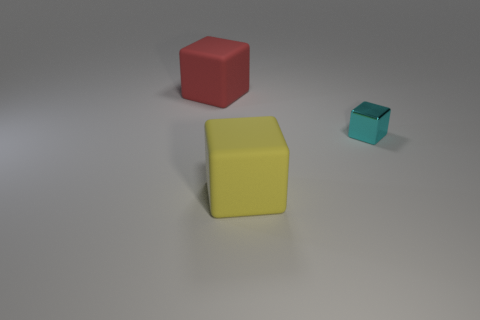Subtract all red cubes. Subtract all cyan spheres. How many cubes are left? 2 Subtract all gray cylinders. How many gray cubes are left? 0 Add 2 yellows. How many cyans exist? 0 Subtract all yellow matte blocks. Subtract all tiny blue cubes. How many objects are left? 2 Add 2 red matte cubes. How many red matte cubes are left? 3 Add 1 large yellow objects. How many large yellow objects exist? 2 Add 3 big yellow matte things. How many objects exist? 6 Subtract all cyan cubes. How many cubes are left? 2 Subtract all tiny cyan cubes. How many cubes are left? 2 Subtract 1 red cubes. How many objects are left? 2 